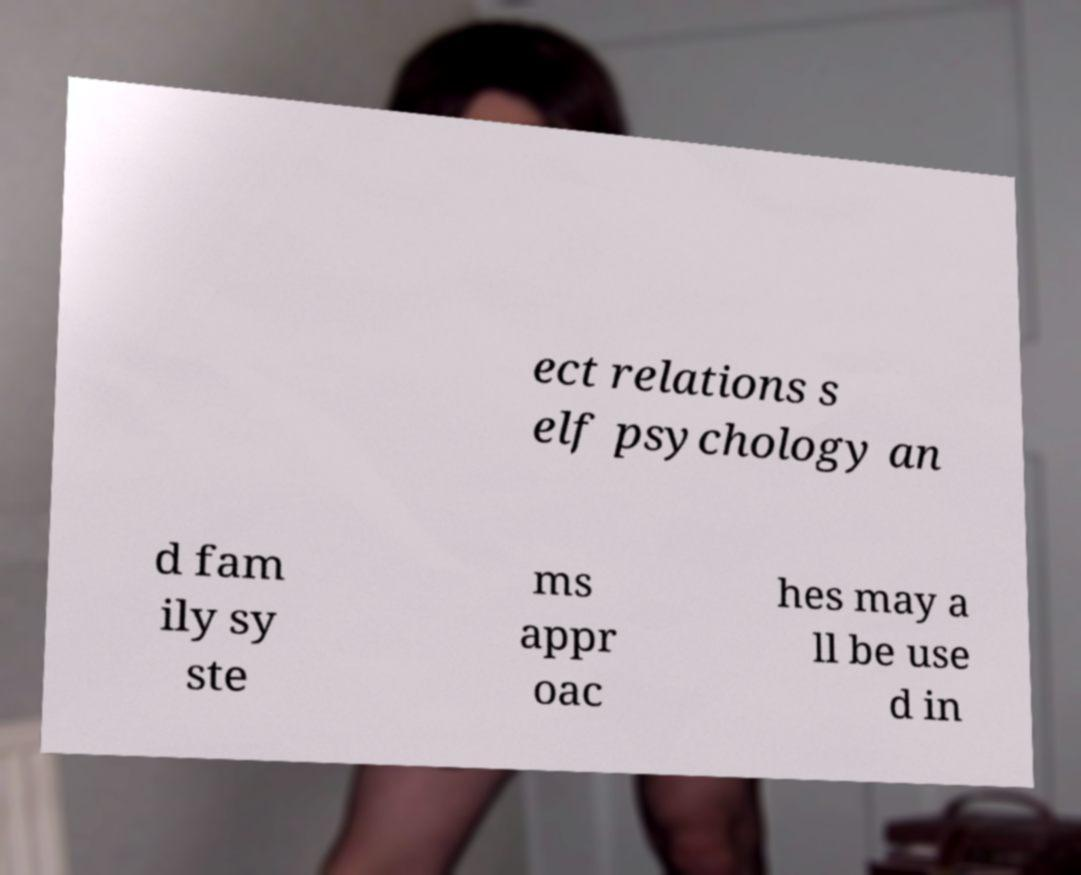Please identify and transcribe the text found in this image. ect relations s elf psychology an d fam ily sy ste ms appr oac hes may a ll be use d in 